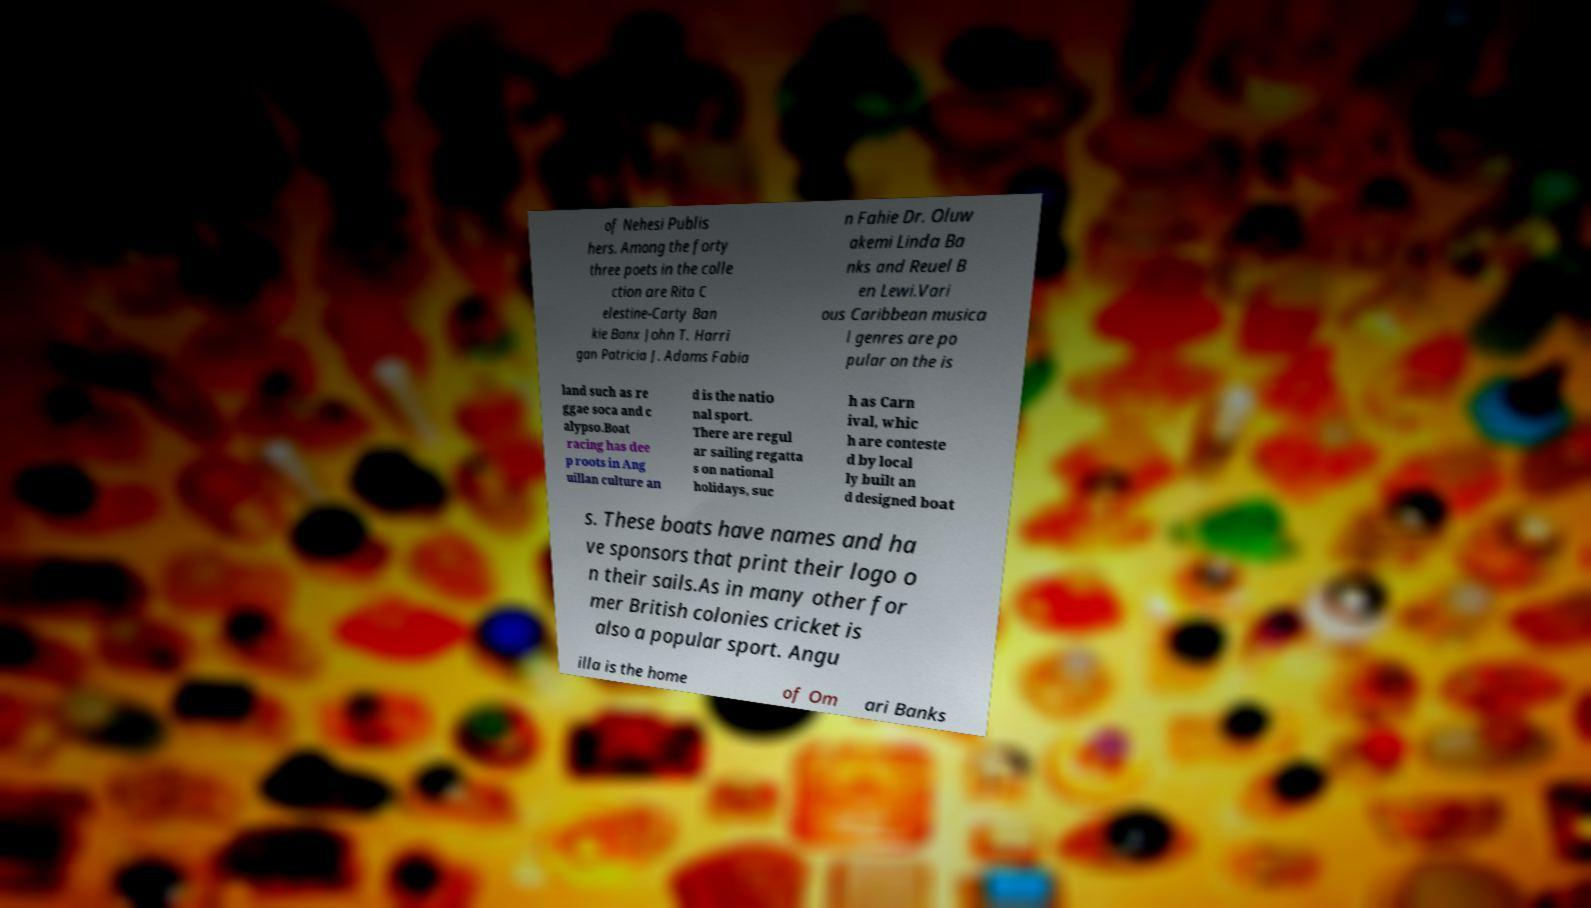Can you read and provide the text displayed in the image?This photo seems to have some interesting text. Can you extract and type it out for me? of Nehesi Publis hers. Among the forty three poets in the colle ction are Rita C elestine-Carty Ban kie Banx John T. Harri gan Patricia J. Adams Fabia n Fahie Dr. Oluw akemi Linda Ba nks and Reuel B en Lewi.Vari ous Caribbean musica l genres are po pular on the is land such as re ggae soca and c alypso.Boat racing has dee p roots in Ang uillan culture an d is the natio nal sport. There are regul ar sailing regatta s on national holidays, suc h as Carn ival, whic h are conteste d by local ly built an d designed boat s. These boats have names and ha ve sponsors that print their logo o n their sails.As in many other for mer British colonies cricket is also a popular sport. Angu illa is the home of Om ari Banks 